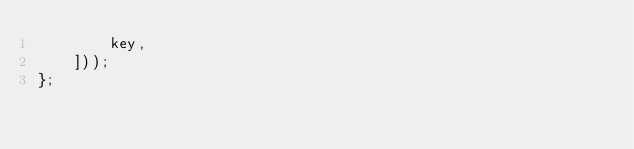<code> <loc_0><loc_0><loc_500><loc_500><_JavaScript_>        key,
    ]));
};
</code> 